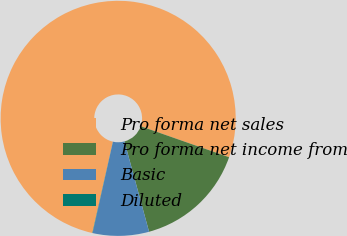<chart> <loc_0><loc_0><loc_500><loc_500><pie_chart><fcel>Pro forma net sales<fcel>Pro forma net income from<fcel>Basic<fcel>Diluted<nl><fcel>76.84%<fcel>15.4%<fcel>7.72%<fcel>0.04%<nl></chart> 